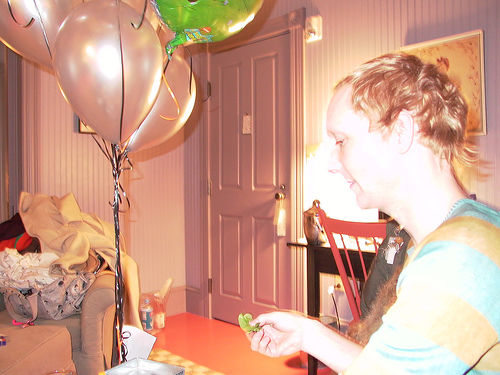<image>
Can you confirm if the person is next to the door? Yes. The person is positioned adjacent to the door, located nearby in the same general area. 